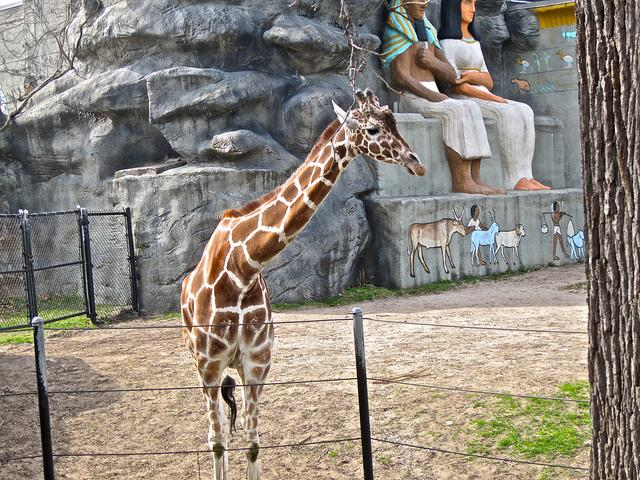Why are the fences lower than the giraffe's neck?

Choices:
A) allow visibility
B) avoid entanglement
C) stop wildlife
D) filter light avoid entanglement 